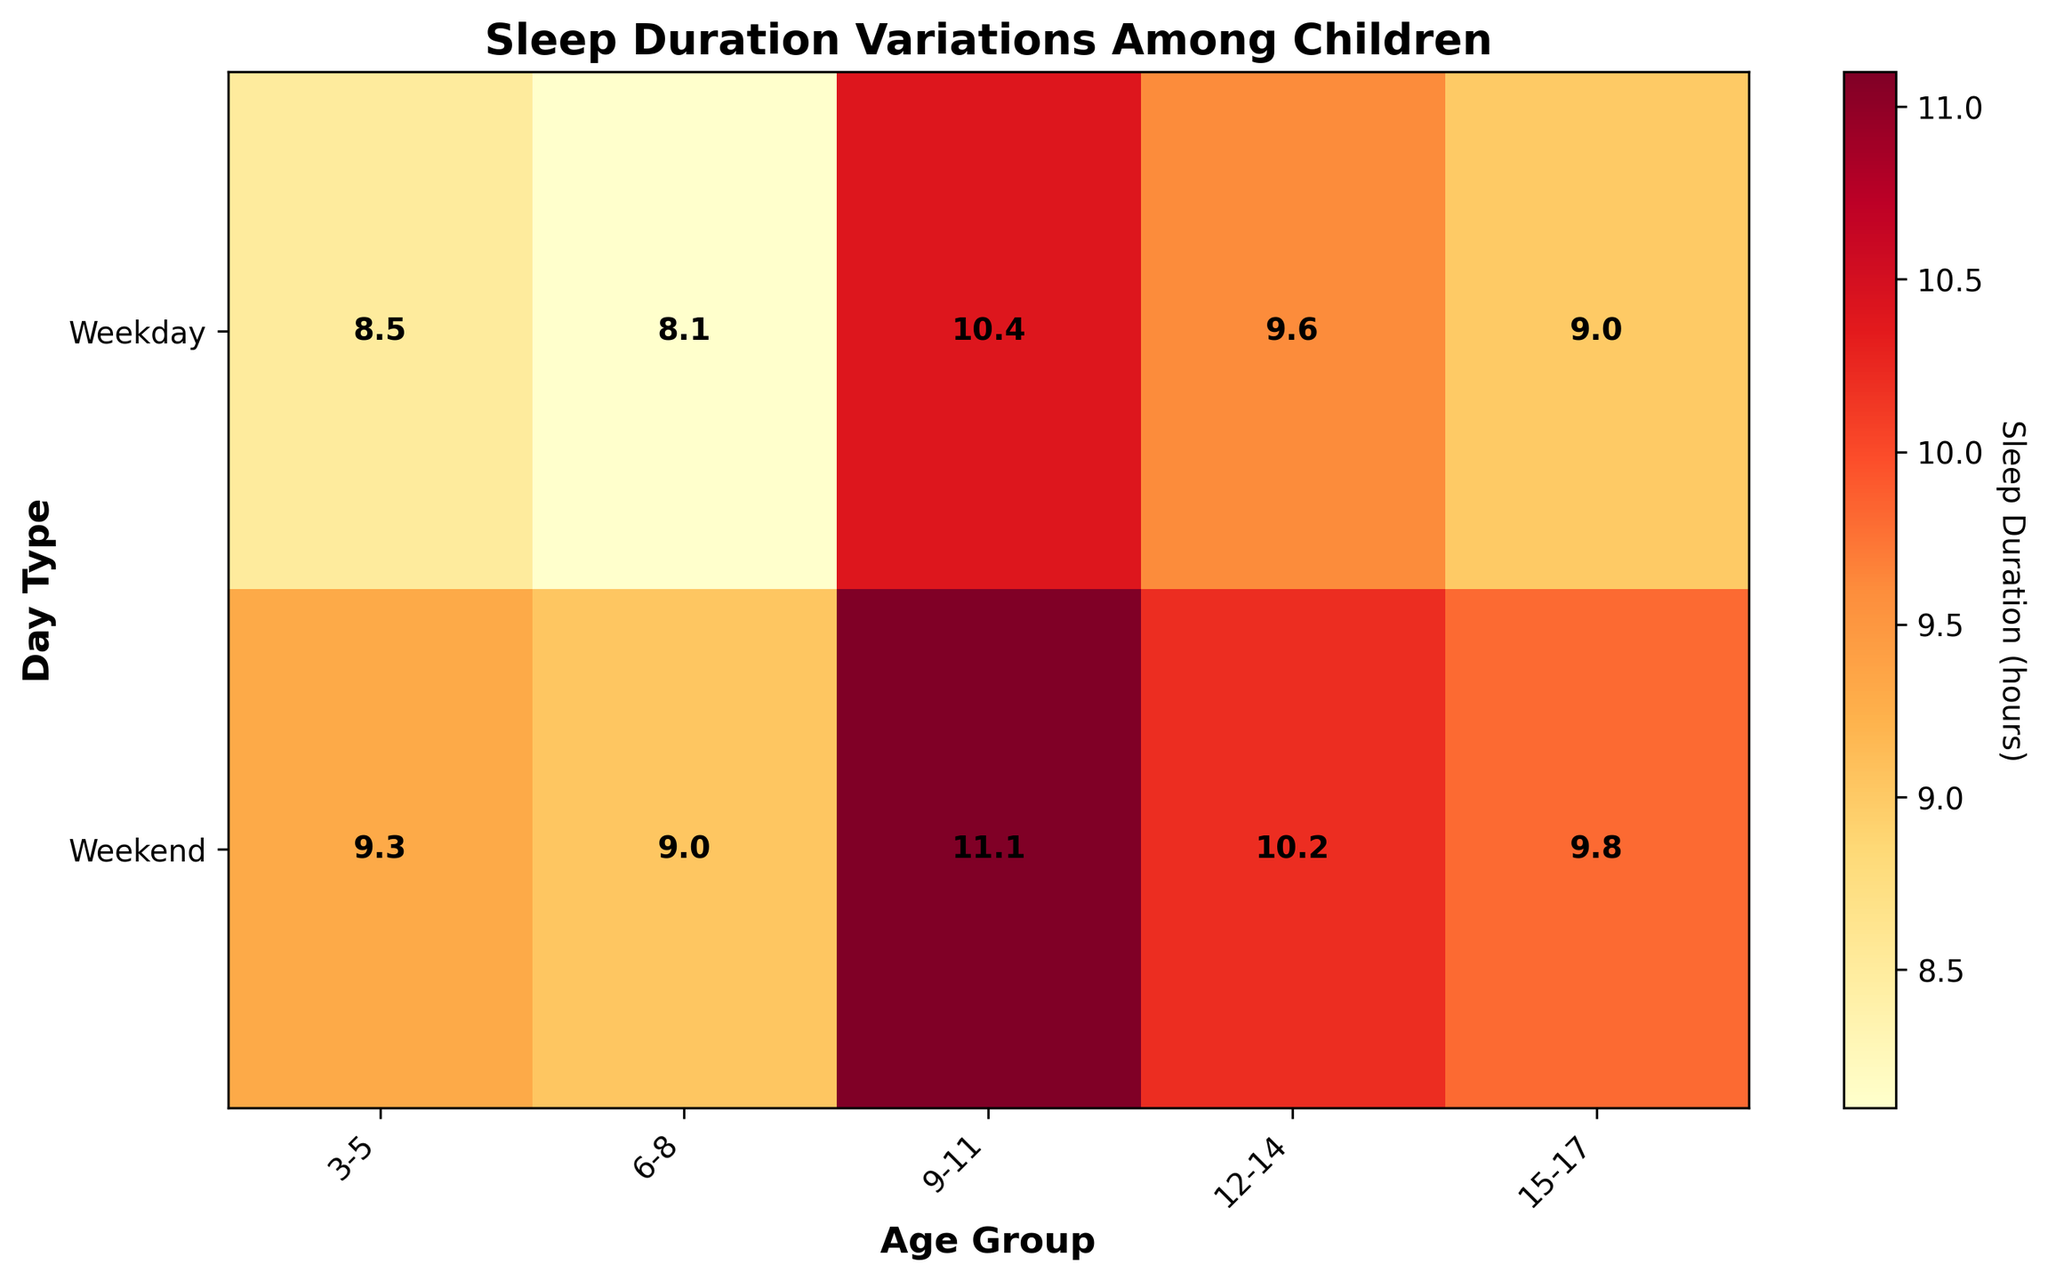What does the title of the heatmap say? The title is written at the top of the heatmap and provides an overall idea of what the chart is about. In this case, the title is "Sleep Duration Variations Among Children". It suggests that the figure examines the differences in sleep durations among children categorized by different factors.
Answer: Sleep Duration Variations Among Children What does the x-axis represent in the heatmap? The x-axis contains labels that indicate different categorical groups. In the heatmap, the x-axis represents the different age groups of children, which are listed as "3-5", "6-8", "9-11", "12-14", and "15-17".
Answer: Age groups of children What are the labels on the y-axis? The y-axis usually represents categories in a heatmap. Here, it has two labels: "Weekday" and "Weekend", which categorize the type of day for the sleep durations measured.
Answer: Weekday and Weekend Which age group has the longest sleep duration on weekends? Look for the highest value across the row labeled "Weekend". The weekend sleep durations are highlighted with the numerical values visually represented on the heatmap. The age group "3-5" has the longest sleep duration value on the weekend.
Answer: 3-5 What's the average weekday sleep duration for the "6-8" age group? The figure shows the heatmap with annotations of the average sleep durations. For the age group "6-8" on weekdays, the value shown is 9.6 hours. To confirm the average, the displayed values within the heatmap are accurate.
Answer: 9.6 hours How does the sleep duration change from weekdays to weekends in the "12-14" age group? To answer this, compare the value for "12-14" on weekdays with the value for weekends. The heatmap shows average sleep durations for each category: "12-14" age group sleeps 8.5 hours on weekdays and 9.3 hours on weekends. The difference is 9.3 - 8.5 = 0.8 hours.
Answer: Increases by 0.8 hours Which day type has consistently longer sleep duration among all age groups? To determine this, examine and compare the values across all age groups for weekdays versus weekends. The values on the weekend row are consistently higher than the corresponding weekday values for all age groups.
Answer: Weekends Which age group shows the smallest difference in sleep duration between weekdays and weekends? Calculate the difference for each age group by subtracting weekday sleep duration from weekend sleep duration, and find the minimum difference. Here are the differences: 
- "3-5": 11.0 - 10.4 ≈ 0.6
- "6-8": 10.2 - 9.6 ≈ 0.6
- "9-11": 9.8 - 9.0 ≈ 0.8
- "12-14": 9.3 - 8.5 ≈ 0.8 
- "15-17": 9.0 - 8.1 ≈ 0.9
Thus, the age groups "3-5" and "6-8" have the smallest difference of around 0.6 hours.
Answer: 3-5 and 6-8 What is the color used to represent the highest sleep durations in the heatmap? The heatmap uses a color scheme to represent sleep durations. Based on the provided code and common heatmap conventions, the color representing the highest values is likely a darker or more intense shade in the 'YlOrRd' colormap used, typically darker red.
Answer: Darker red 